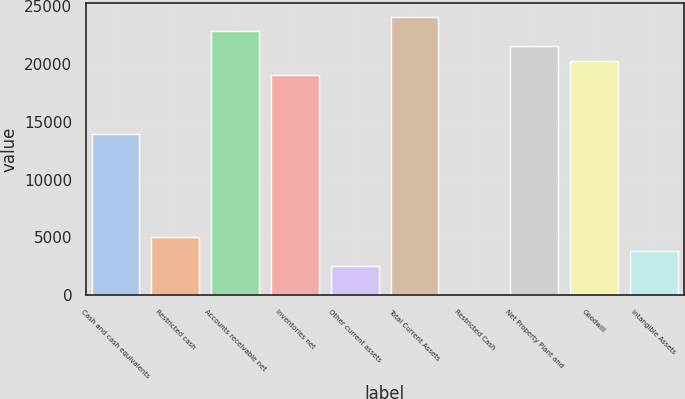Convert chart. <chart><loc_0><loc_0><loc_500><loc_500><bar_chart><fcel>Cash and cash equivalents<fcel>Restricted cash<fcel>Accounts receivable net<fcel>Inventories net<fcel>Other current assets<fcel>Total Current Assets<fcel>Restricted Cash<fcel>Net Property Plant and<fcel>Goodwill<fcel>Intangible Assets<nl><fcel>13935.7<fcel>5068.7<fcel>22802.8<fcel>19002.6<fcel>2535.26<fcel>24069.5<fcel>1.82<fcel>21536.1<fcel>20269.3<fcel>3801.98<nl></chart> 